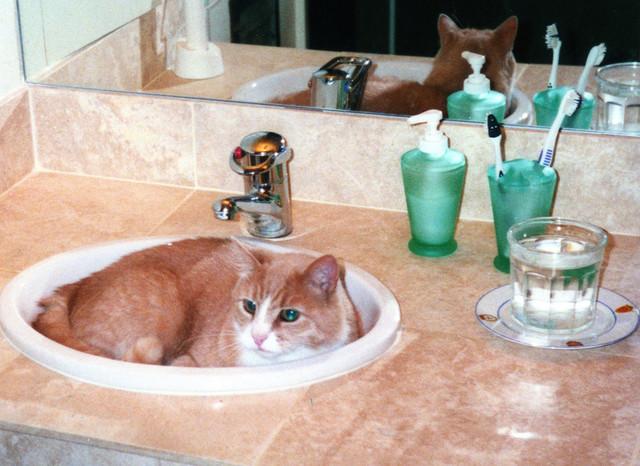Would the cat like it if you turned on the faucet?
Give a very brief answer. No. What room is this cat in?
Keep it brief. Bathroom. Do you think that cat looks nice?
Short answer required. Yes. 